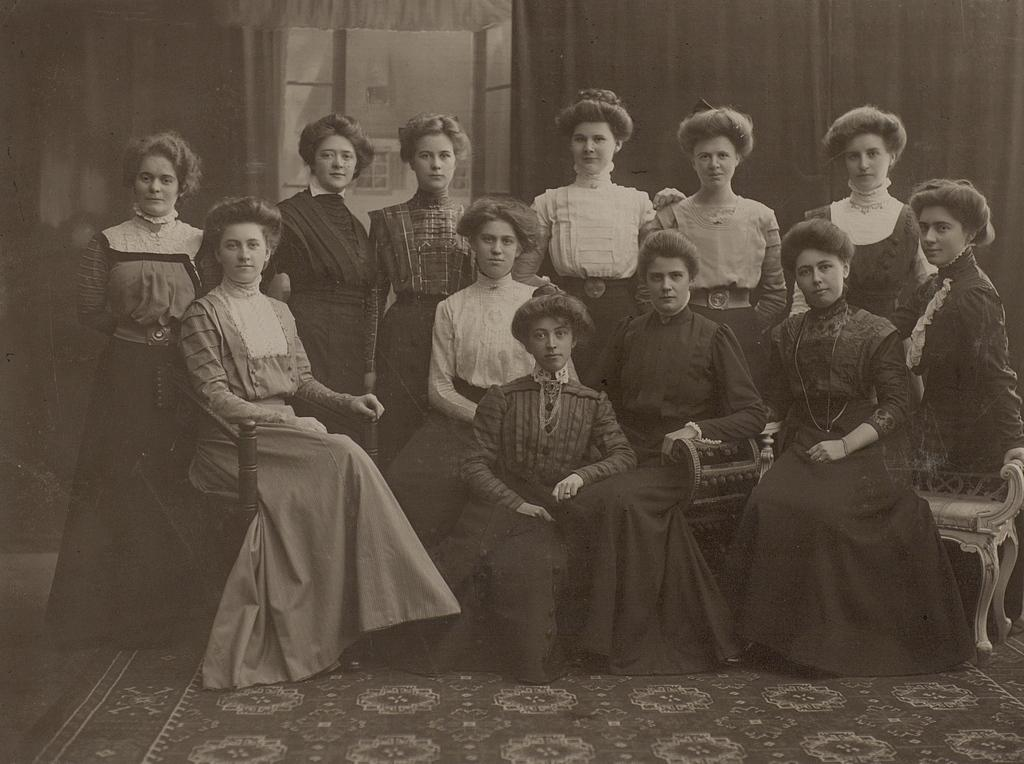What can be observed about the people in the image? There is a group of people in the image, with some sitting on chairs and others standing. Can you describe the setting in which the people are located? There is a wall visible in the background of the image. What is the color scheme of the image? The image is black and white. What type of soup is being served to the girl in the image? There is no girl or soup present in the image; it features a group of people with some sitting and others standing in a black and white setting. 